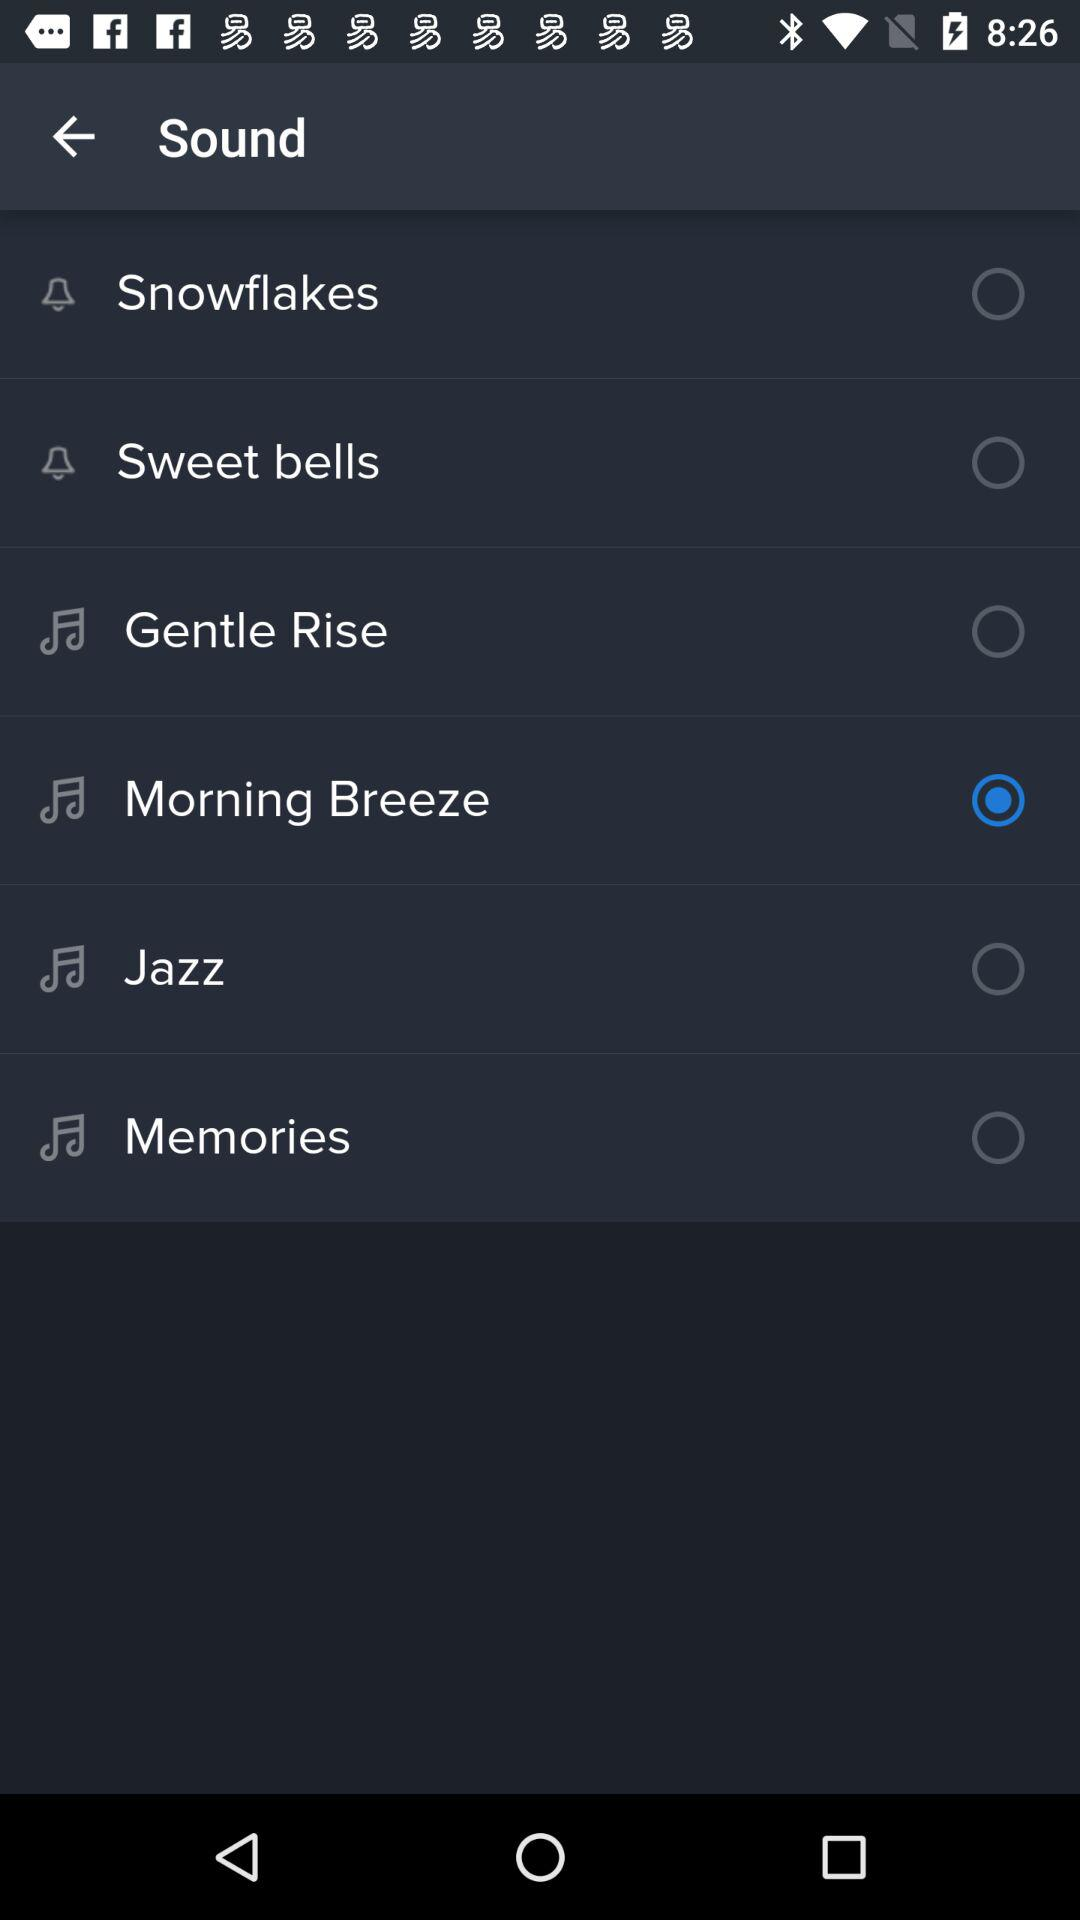What are the options available for the sound in the list? The available options are "Snowflakes", "Sweet bells", "Gentle Rise", "Morning Breeze", "Jazz" and "Memories". 